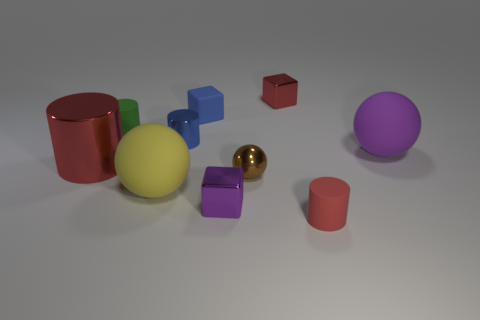Subtract all tiny green cylinders. How many cylinders are left? 3 Subtract all cyan balls. How many red cylinders are left? 2 Subtract all brown spheres. How many spheres are left? 2 Subtract 1 spheres. How many spheres are left? 2 Subtract 0 red balls. How many objects are left? 10 Subtract all cylinders. How many objects are left? 6 Subtract all brown cubes. Subtract all blue spheres. How many cubes are left? 3 Subtract all small red things. Subtract all purple cubes. How many objects are left? 7 Add 2 blocks. How many blocks are left? 5 Add 9 purple shiny things. How many purple shiny things exist? 10 